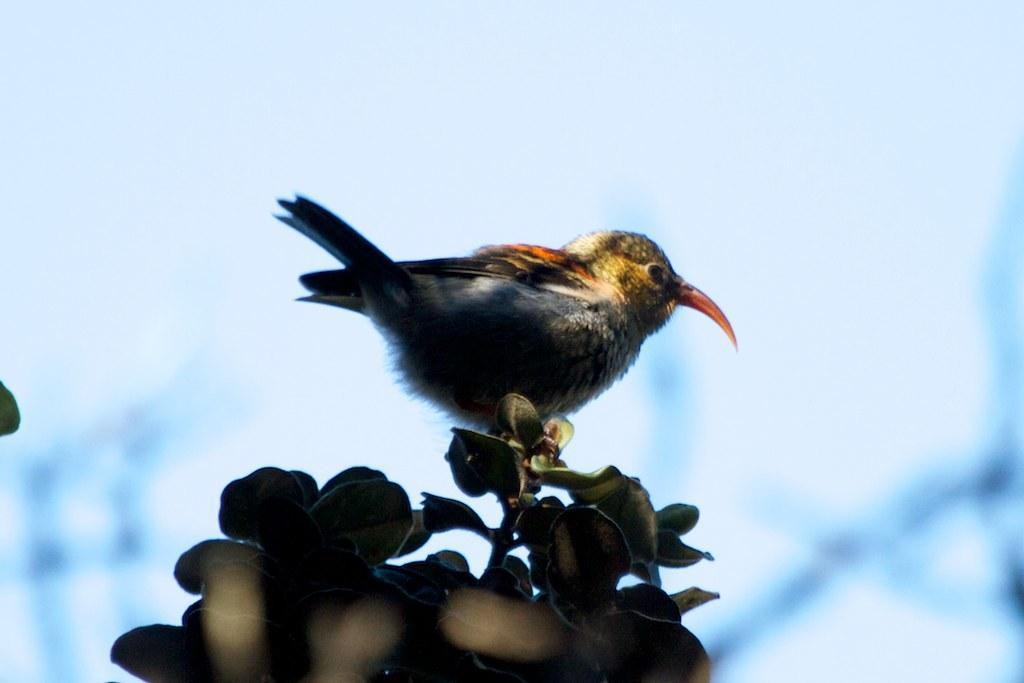Can you describe this image briefly? This image is taken outdoors. In the background there is the sky. In the middle of the image there is a plant with leaves and stems and there is a bird on the plant. The bird is with a long beak. 